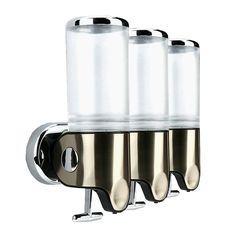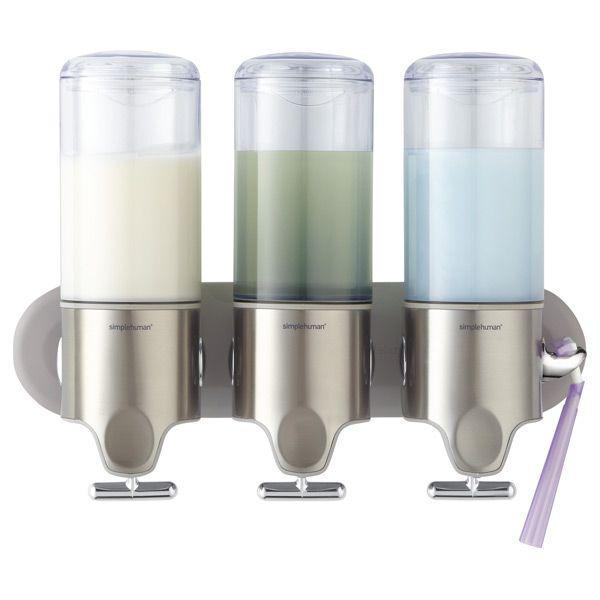The first image is the image on the left, the second image is the image on the right. Examine the images to the left and right. Is the description "The left image contains a human hand." accurate? Answer yes or no. No. 